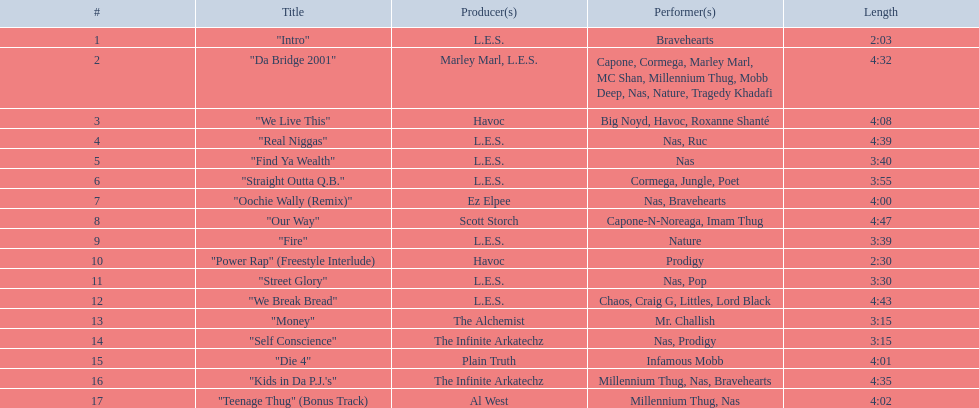What are the track durations on the nas & ill will records presents qb's finest album? 2:03, 4:32, 4:08, 4:39, 3:40, 3:55, 4:00, 4:47, 3:39, 2:30, 3:30, 4:43, 3:15, 3:15, 4:01, 4:35, 4:02. Which one is the most extended? 4:47. 